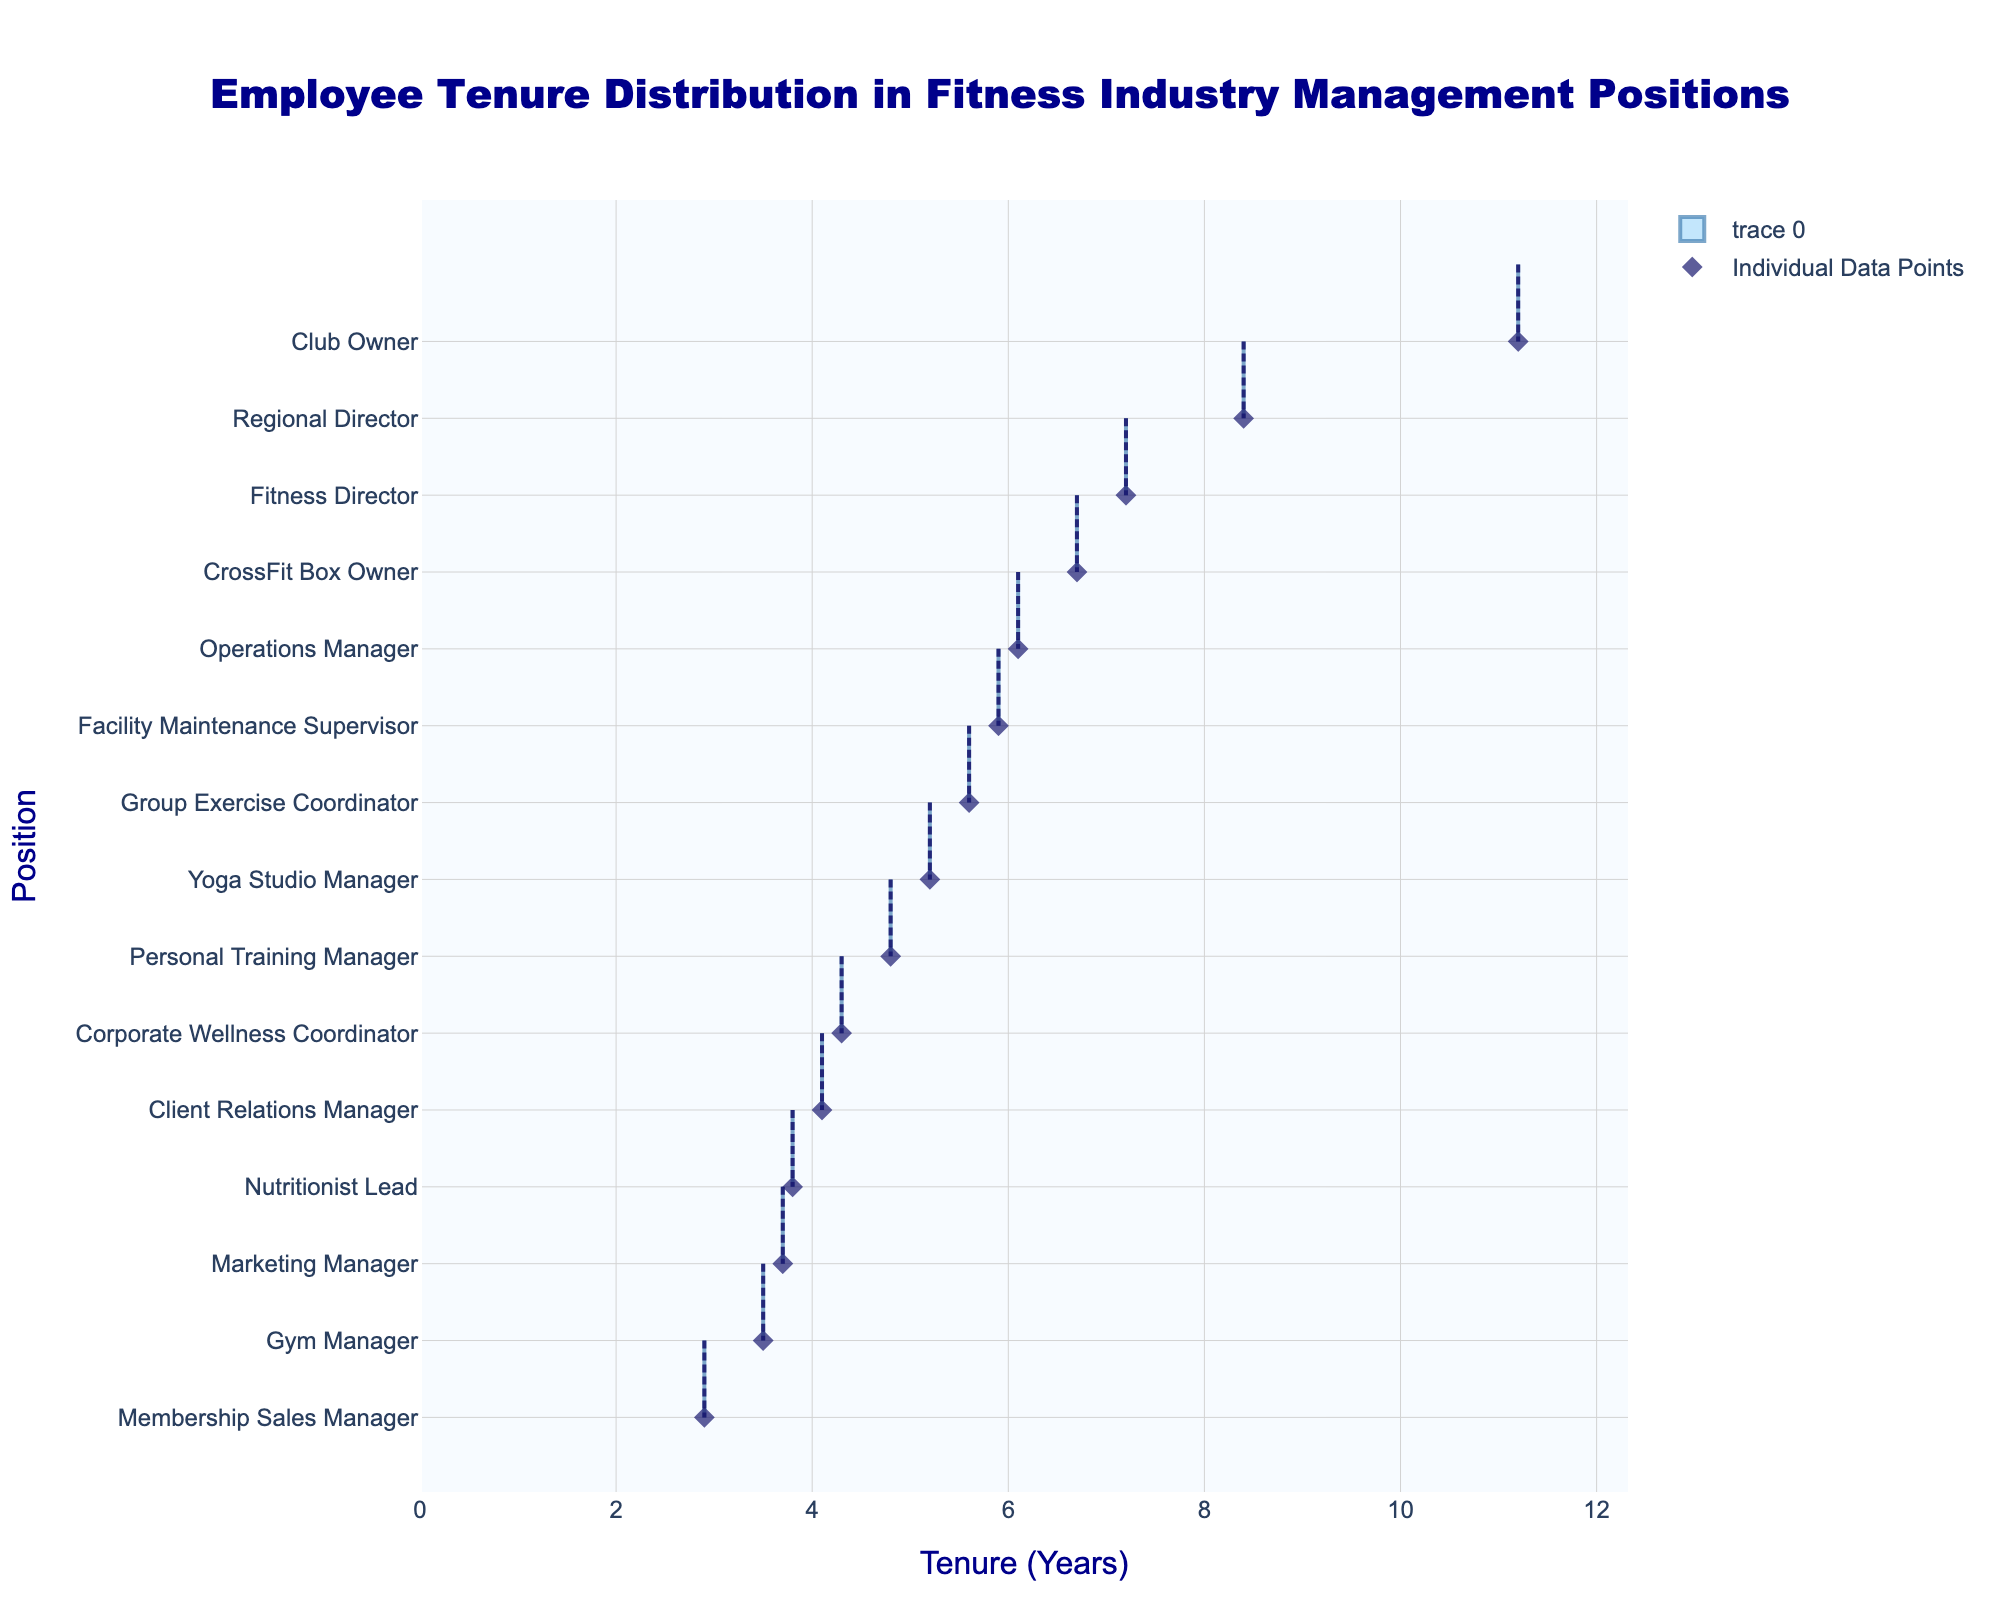What's the title of the plot? The title of the plot is prominently displayed at the top and reads "Employee Tenure Distribution in Fitness Industry Management Positions"
Answer: "Employee Tenure Distribution in Fitness Industry Management Positions" What is the range of tenure years displayed on the x-axis? The x-axis range is customized to display from 0 to slightly above the maximum tenure in the dataset, which is 11.2 years. So, the range would approximately be from 0 to 12.5 years.
Answer: 0 to 12.5 years Which position has the highest average tenure? In the density plot, the average tenure is indicated by a meanline within each position's distribution. The longest average tenure line is observed at "Club Owner" with approximately 11.2 years.
Answer: Club Owner How many positions have an average tenure of over 6 years? By locating the thick mean lines that denote the average tenure in the plot, we identify the mean lines above 6 years. These positions are: Fitness Director, Operations Manager, Regional Director, CrossFit Box Owner, and Club Owner.
Answer: 5 What is the average tenure of a Gym Manager and a Marketing Manager together? From the plot, we see the mean lines for Gym Manager (3.5 years) and Marketing Manager (3.7 years). The average in total is (3.5 + 3.7) / 2.
Answer: 3.6 years Which three positions observe the least tenure years on average? The positions with the shortest average tenure are found at the extreme left of the plot: Membership Sales Manager, Gym Manager, and Marketing Manager.
Answer: Membership Sales Manager, Gym Manager, Marketing Manager How does the tenure distribution of a Fitness Director compare to that of a Personal Training Manager? The Fitness Director shows a longer tenure distribution with the mean closer to 7.2 years, while the Personal Training Manager has a mean around 4.8 years, indicating greater tenure for Fitness Directors compared to Personal Training Managers.
Answer: Fitness Director has greater tenure What is the tenure range for the Membership Sales Manager? Examining the density distribution for Membership Sales Manager, we see it ranges approximately between 2 and 4 years.
Answer: 2 to 4 years Do any positions' tenures span the entire length of the x-axis? None of the positions have a tenure distribution spanning from 0 to the maximum 12.5 years; each distribution is localized within a specific range.
Answer: No Which role has the closest tenure distribution clustering around its mean? By observing the width and spread of the density plots, the Regional Director shows a tightly clustered distribution around an 8.4 years mean indicating closely grouped tenure values.
Answer: Regional Director 